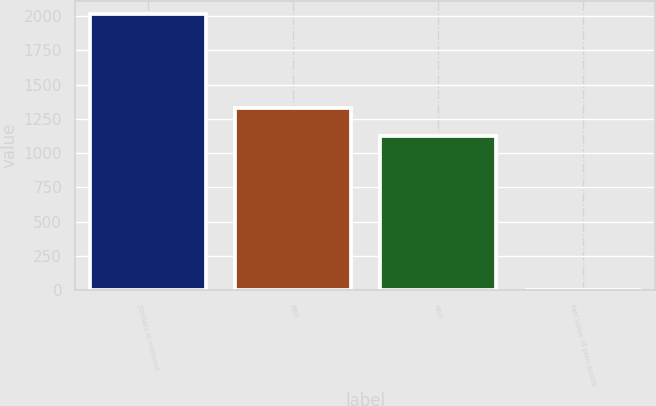Convert chart. <chart><loc_0><loc_0><loc_500><loc_500><bar_chart><fcel>(Dollars in millions)<fcel>PBO<fcel>ABO<fcel>Fair value of plan assets<nl><fcel>2013<fcel>1327.1<fcel>1126<fcel>2<nl></chart> 